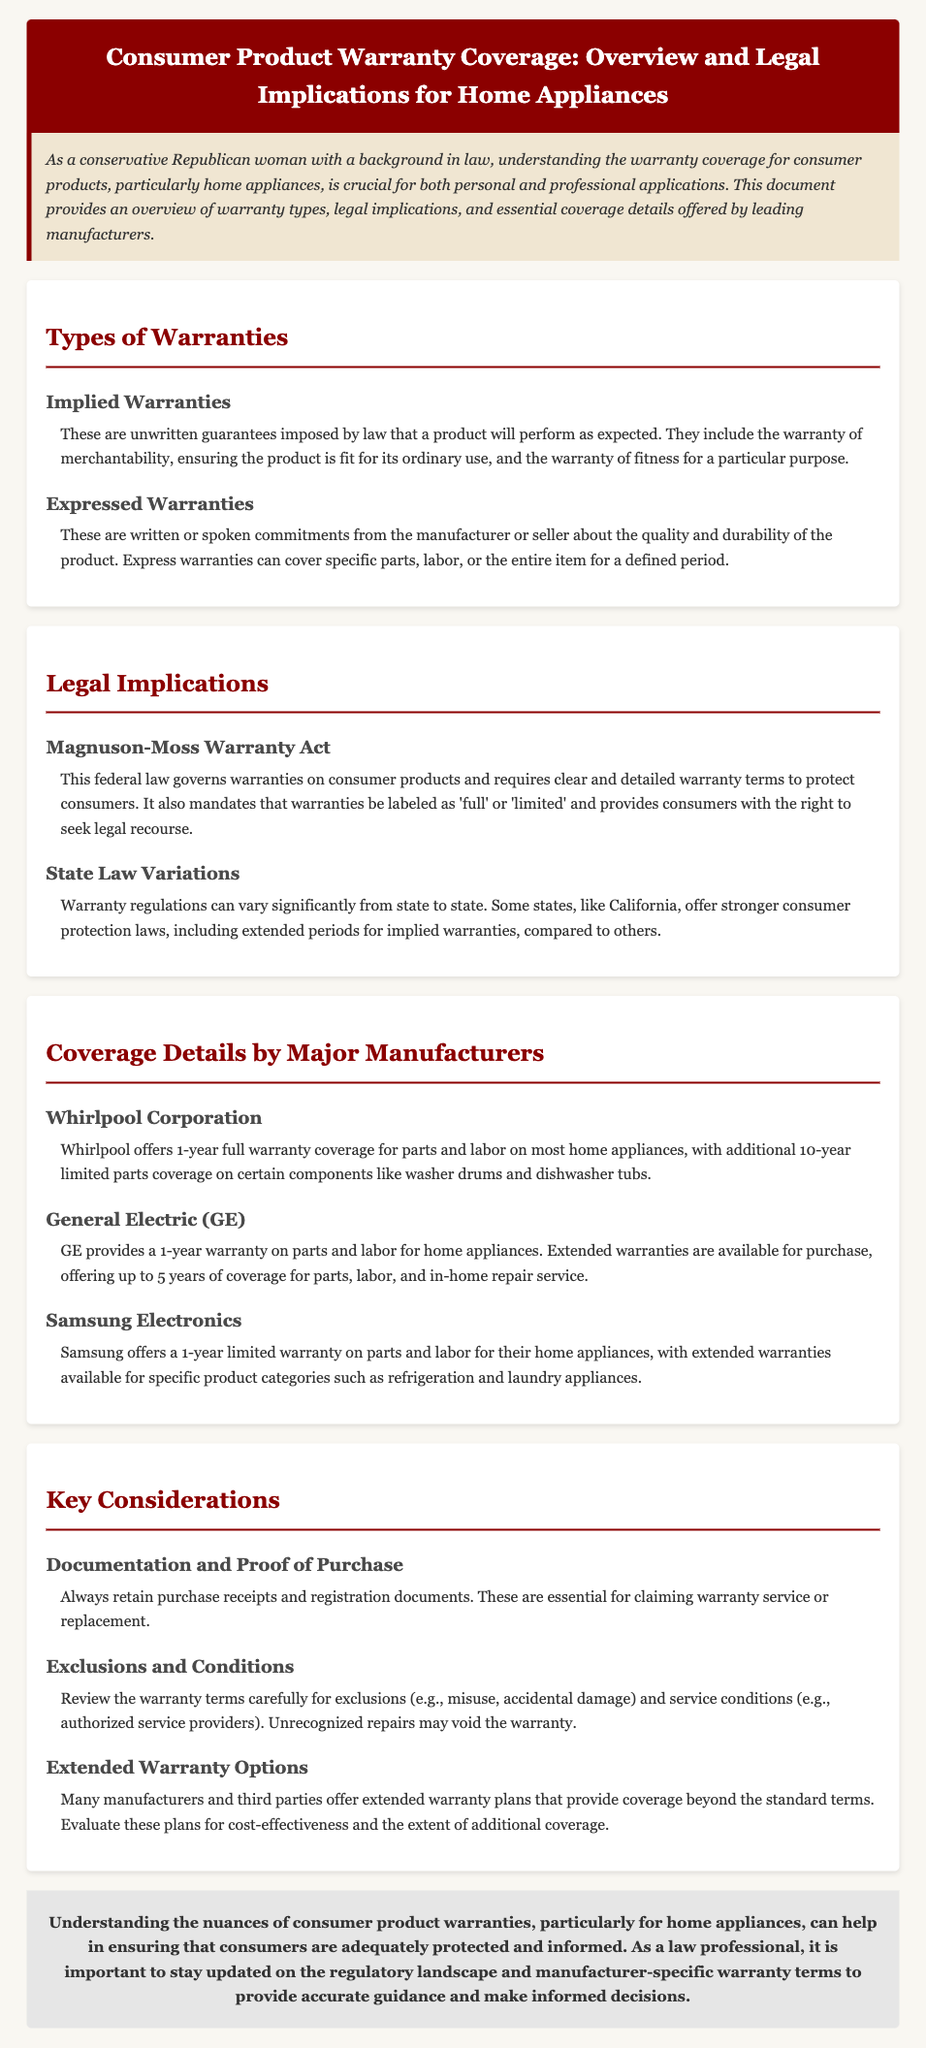What are the two types of warranties mentioned? The document lists two types of warranties: Implied and Expressed.
Answer: Implied and Expressed What federal law governs warranties on consumer products? The Magnuson-Moss Warranty Act is mentioned as the governing federal law.
Answer: Magnuson-Moss Warranty Act How long is the standard warranty provided by Whirlpool Corporation? Whirlpool Corporation offers a 1-year full warranty coverage on most home appliances.
Answer: 1-year What should consumers retain for claiming warranty service? The document emphasizes the importance of retaining purchase receipts and registration documents.
Answer: Purchase receipts and registration documents What extended warranty coverage does GE provide? Extended warranties for GE offer up to 5 years of coverage for parts, labor, and in-home repair service.
Answer: Up to 5 years What is a key consideration regarding warranty terms? Exclusions and conditions are noted as a key consideration in understanding warranty terms.
Answer: Exclusions and conditions Which manufacturer offers a limited warranty on refrigeration and laundry appliances? Samsung Electronics is noted to offer a limited warranty on specific product categories such as refrigeration and laundry appliances.
Answer: Samsung Electronics What does the warranty of merchantability ensure? The warranty of merchantability ensures that the product is fit for its ordinary use.
Answer: Fit for its ordinary use What can vary significantly from state to state regarding warranties? Warranty regulations are noted to vary significantly from state to state.
Answer: Warranty regulations 